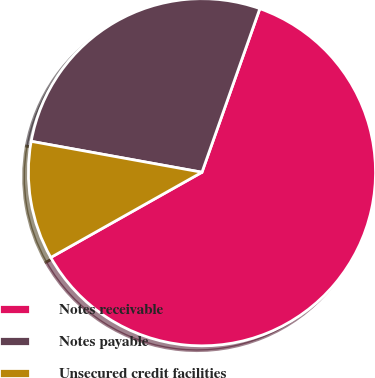Convert chart. <chart><loc_0><loc_0><loc_500><loc_500><pie_chart><fcel>Notes receivable<fcel>Notes payable<fcel>Unsecured credit facilities<nl><fcel>61.42%<fcel>27.56%<fcel>11.02%<nl></chart> 